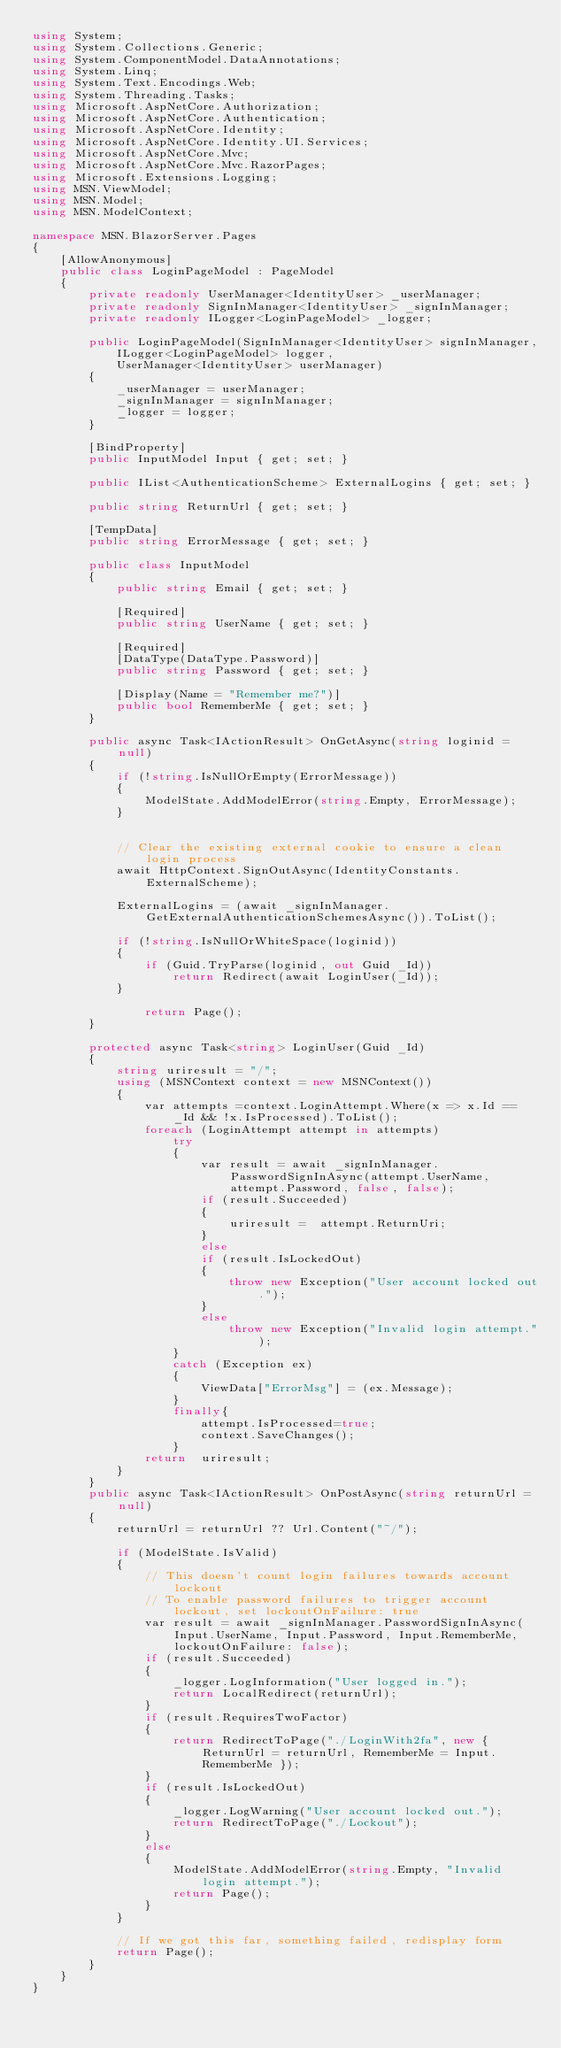Convert code to text. <code><loc_0><loc_0><loc_500><loc_500><_C#_>using System;
using System.Collections.Generic;
using System.ComponentModel.DataAnnotations;
using System.Linq;
using System.Text.Encodings.Web;
using System.Threading.Tasks;
using Microsoft.AspNetCore.Authorization;
using Microsoft.AspNetCore.Authentication;
using Microsoft.AspNetCore.Identity;
using Microsoft.AspNetCore.Identity.UI.Services;
using Microsoft.AspNetCore.Mvc;
using Microsoft.AspNetCore.Mvc.RazorPages;
using Microsoft.Extensions.Logging;
using MSN.ViewModel;
using MSN.Model;
using MSN.ModelContext;

namespace MSN.BlazorServer.Pages
{
    [AllowAnonymous]
    public class LoginPageModel : PageModel
    {
        private readonly UserManager<IdentityUser> _userManager;
        private readonly SignInManager<IdentityUser> _signInManager;
        private readonly ILogger<LoginPageModel> _logger;

        public LoginPageModel(SignInManager<IdentityUser> signInManager,
            ILogger<LoginPageModel> logger,
            UserManager<IdentityUser> userManager)
        {
            _userManager = userManager;
            _signInManager = signInManager;
            _logger = logger;
        }

        [BindProperty]
        public InputModel Input { get; set; }

        public IList<AuthenticationScheme> ExternalLogins { get; set; }

        public string ReturnUrl { get; set; }

        [TempData]
        public string ErrorMessage { get; set; }

        public class InputModel
        {
            public string Email { get; set; }

            [Required]
            public string UserName { get; set; }

            [Required]
            [DataType(DataType.Password)]
            public string Password { get; set; }

            [Display(Name = "Remember me?")]
            public bool RememberMe { get; set; }
        }

        public async Task<IActionResult> OnGetAsync(string loginid = null)
        {
            if (!string.IsNullOrEmpty(ErrorMessage))
            {
                ModelState.AddModelError(string.Empty, ErrorMessage);
            }


            // Clear the existing external cookie to ensure a clean login process
            await HttpContext.SignOutAsync(IdentityConstants.ExternalScheme);

            ExternalLogins = (await _signInManager.GetExternalAuthenticationSchemesAsync()).ToList();

            if (!string.IsNullOrWhiteSpace(loginid))
            {
                if (Guid.TryParse(loginid, out Guid _Id))
                    return Redirect(await LoginUser(_Id));
            }

                return Page();
        }

        protected async Task<string> LoginUser(Guid _Id)
        {
            string uriresult = "/";
            using (MSNContext context = new MSNContext())
            {
                var attempts =context.LoginAttempt.Where(x => x.Id == _Id && !x.IsProcessed).ToList();
                foreach (LoginAttempt attempt in attempts)
                    try
                    {
                        var result = await _signInManager.PasswordSignInAsync(attempt.UserName, attempt.Password, false, false);
                        if (result.Succeeded)
                        {
                            uriresult =  attempt.ReturnUri;
                        }
                        else
                        if (result.IsLockedOut)
                        {
                            throw new Exception("User account locked out.");
                        }
                        else
                            throw new Exception("Invalid login attempt.");
                    }
                    catch (Exception ex)
                    {
                        ViewData["ErrorMsg"] = (ex.Message);
                    }
                    finally{
                        attempt.IsProcessed=true;
                        context.SaveChanges();
                    }
                return  uriresult;
            }
        }
        public async Task<IActionResult> OnPostAsync(string returnUrl = null)
        {
            returnUrl = returnUrl ?? Url.Content("~/");

            if (ModelState.IsValid)
            {
                // This doesn't count login failures towards account lockout
                // To enable password failures to trigger account lockout, set lockoutOnFailure: true
                var result = await _signInManager.PasswordSignInAsync(Input.UserName, Input.Password, Input.RememberMe, lockoutOnFailure: false);
                if (result.Succeeded)
                {
                    _logger.LogInformation("User logged in.");
                    return LocalRedirect(returnUrl);
                }
                if (result.RequiresTwoFactor)
                {
                    return RedirectToPage("./LoginWith2fa", new { ReturnUrl = returnUrl, RememberMe = Input.RememberMe });
                }
                if (result.IsLockedOut)
                {
                    _logger.LogWarning("User account locked out.");
                    return RedirectToPage("./Lockout");
                }
                else
                {
                    ModelState.AddModelError(string.Empty, "Invalid login attempt.");
                    return Page();
                }
            }

            // If we got this far, something failed, redisplay form
            return Page();
        }
    }
}
</code> 